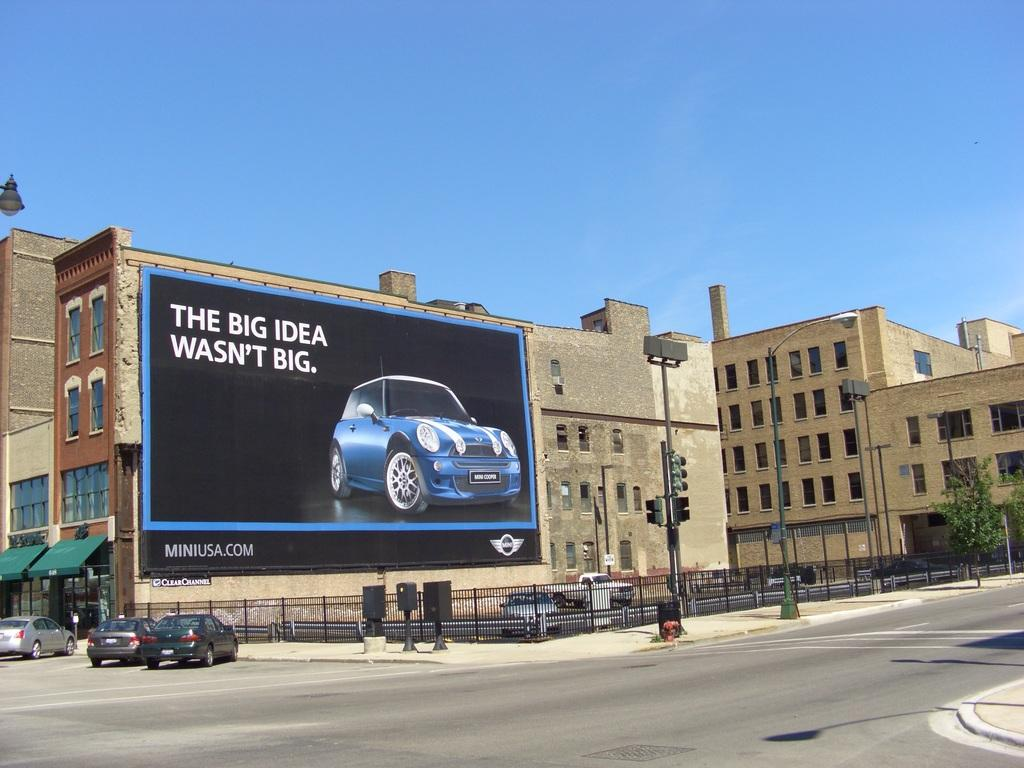<image>
Render a clear and concise summary of the photo. A large billboard against a builiding titled The Big Idea Wasn't Big. 